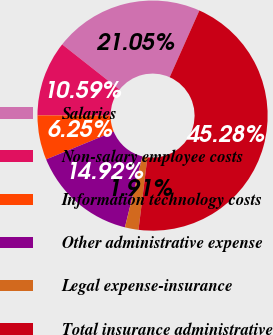<chart> <loc_0><loc_0><loc_500><loc_500><pie_chart><fcel>Salaries<fcel>Non-salary employee costs<fcel>Information technology costs<fcel>Other administrative expense<fcel>Legal expense-insurance<fcel>Total insurance administrative<nl><fcel>21.05%<fcel>10.59%<fcel>6.25%<fcel>14.92%<fcel>1.91%<fcel>45.28%<nl></chart> 